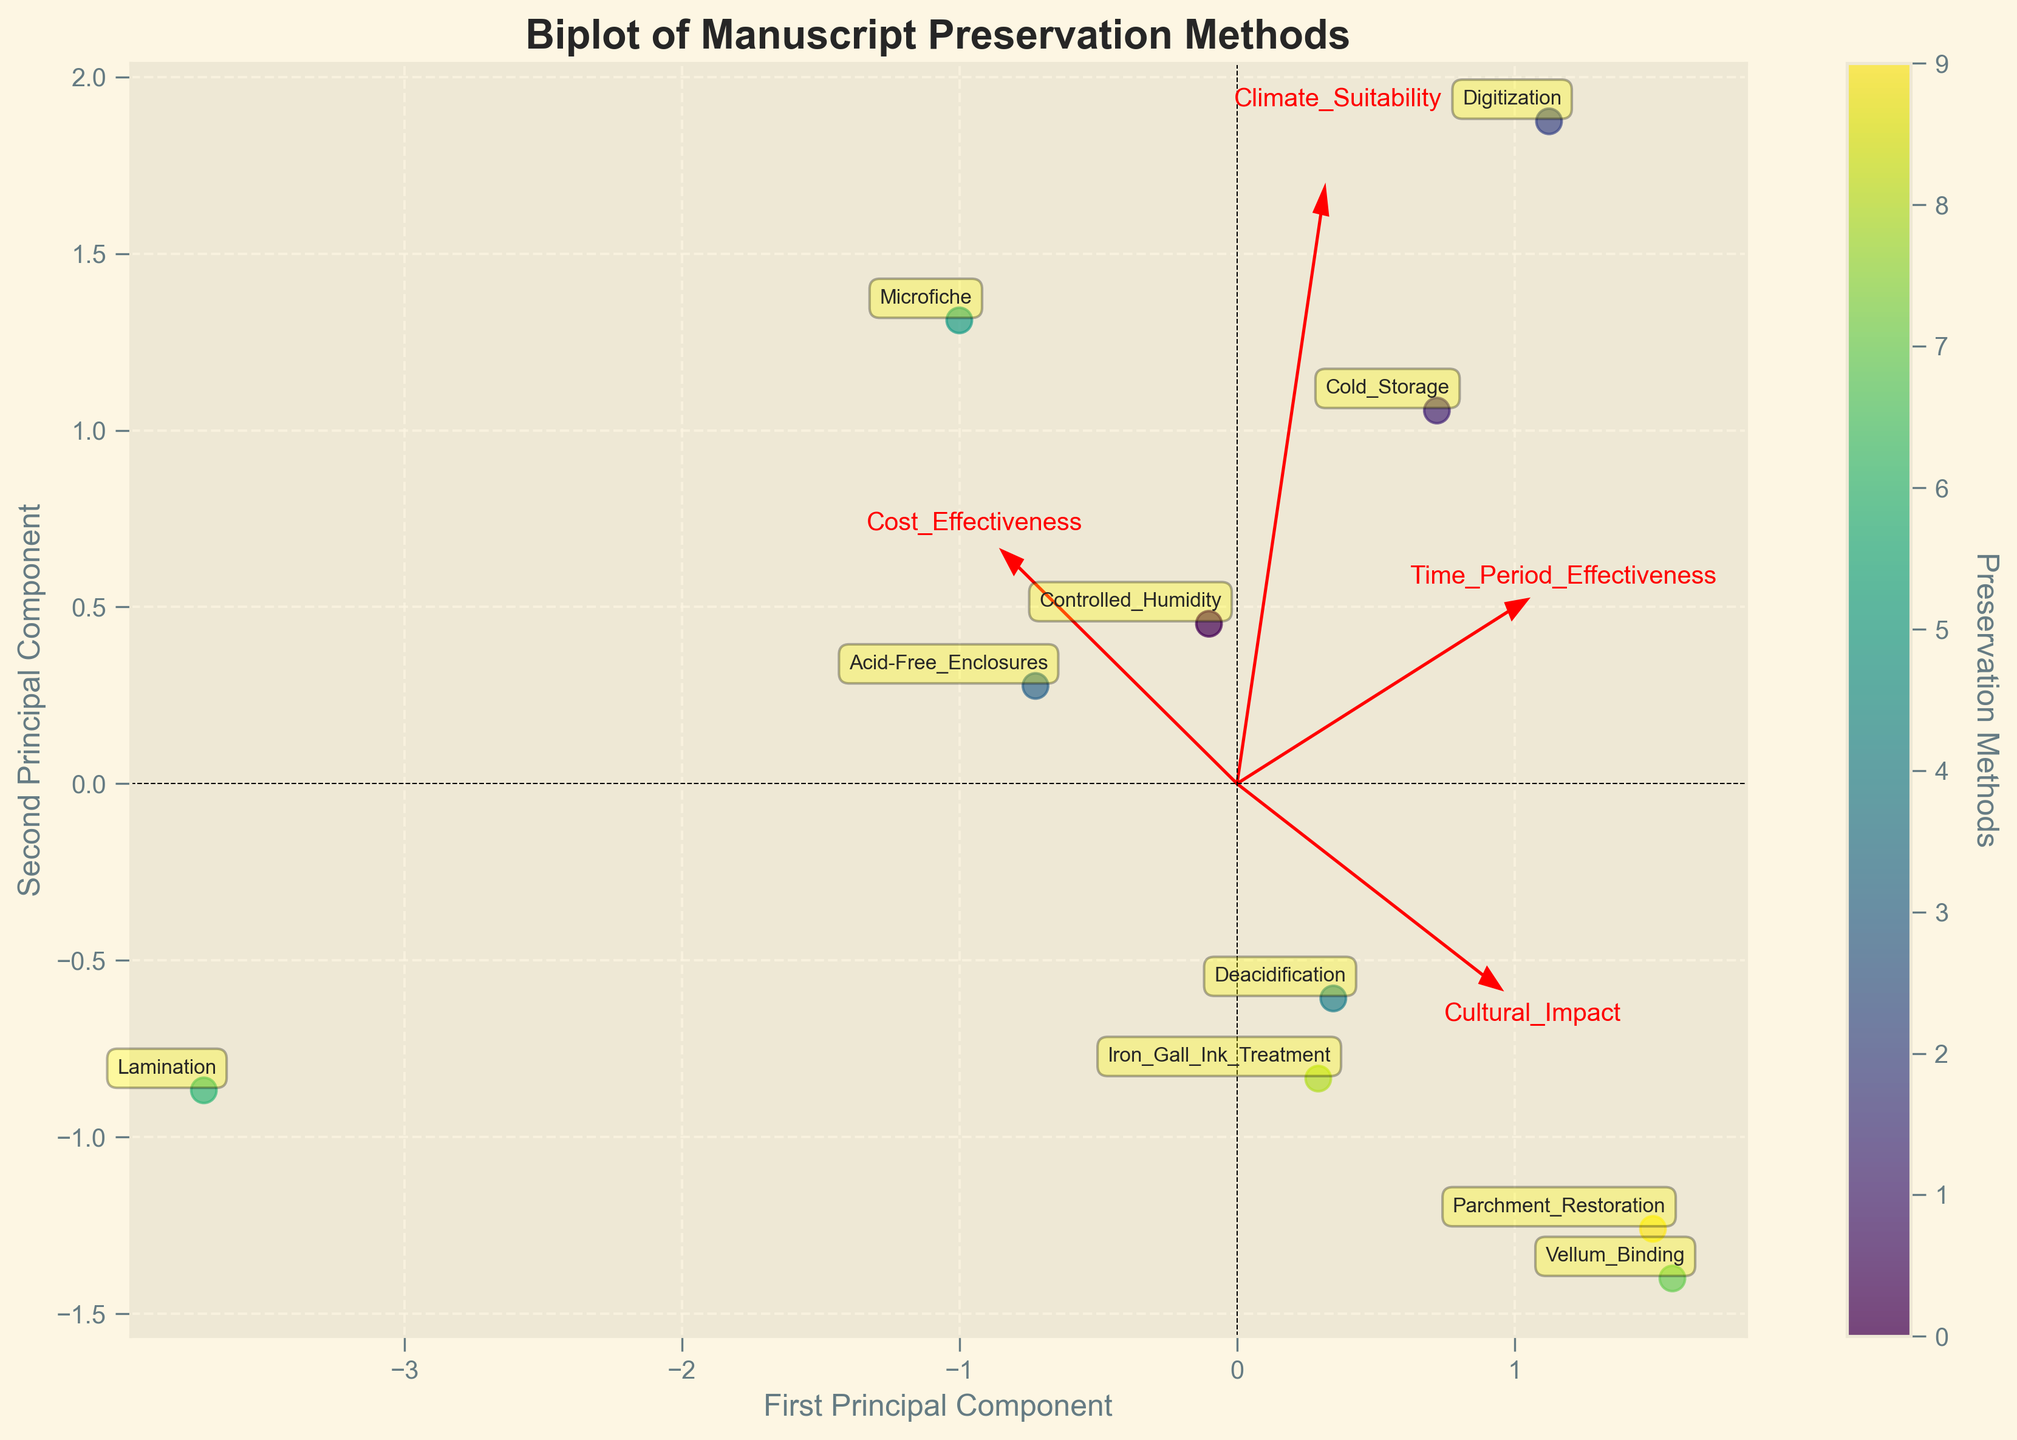What is the title of the plot? The title of the plot is shown at the top of the figure. Examining the figure closely, you can see the bold text which clearly states the title.
Answer: Biplot of Manuscript Preservation Methods How many data points (preservation methods) are represented in the plot? The number of data points can be determined by counting the labels around the points in the plot. Each preservation method corresponds to a distinct point with an annotated label.
Answer: 10 Which preservation method has the highest first principal component (PC1) score? To identify this, you need to observe the x-axis (First Principal Component) and find the point that is farthest to the right. The label of this data point will indicate the preservation method.
Answer: Digitization What is the approximate Climate Suitability score for the preservation method labeled "Lamination"? Look at the plot arrows representing each feature. Follow the direction of the "Climate Suitability" arrow to estimate where the "Lamination" point aligns on that vector.
Answer: Approximately 0.60 Which preservation method has the greatest distance from the origin? The preservation method furthest from the origin can be found by measuring the Euclidean distance from the center (0,0) to each point. By inspecting the plot, you can see which point is farthest away.
Answer: Digitization Which two preservation methods are closest to each other in the plot? To determine this, find the two data points that have the least separation between them. Observe their positions on both the PC1 and PC2 dimensions.
Answer: Controlled Humidity and Iron Gall Ink Treatment Which feature vector is most closely aligned with the first principal component? By examining the direction and length of the feature vectors (red arrows), you can see which one points most closely along the x-axis, indicating alignment with the first principal component.
Answer: Climate Suitability How does "Microfiche" compare to "Cold Storage" in terms of Time Period Effectiveness? To compare, look at the feature vector labeled "Time Period Effectiveness" and see where the projections of "Microfiche" and "Cold Storage" fall along this vector.
Answer: Cold Storage is higher Estimate the coordinates of "Iron Gall Ink Treatment" in terms of the first and second principal components. Locate the label "Iron Gall Ink Treatment" on the plot. Estimate its position along the x-axis (PC1) and y-axis (PC2) by using the grid lines and nearest reference points.
Answer: (0.3, 0.4) Which cultural impact level ranges highest among the preservation methods, considering the plot and feature vectors? Look at how the points are distributed along the "Cultural Impact" arrow. Identify which preservation method lies farthest along this direction.
Answer: Vellum Binding 